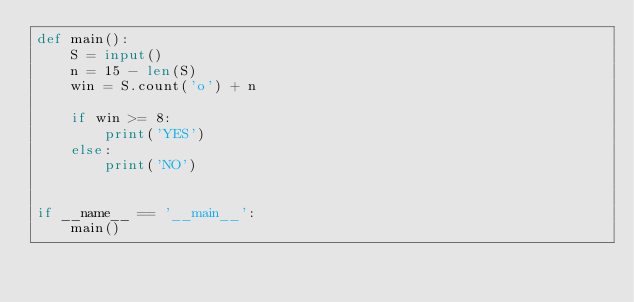Convert code to text. <code><loc_0><loc_0><loc_500><loc_500><_Python_>def main():
    S = input()
    n = 15 - len(S)
    win = S.count('o') + n
    
    if win >= 8:
        print('YES')
    else:
        print('NO')


if __name__ == '__main__':
    main()</code> 